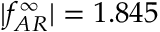Convert formula to latex. <formula><loc_0><loc_0><loc_500><loc_500>| f _ { A R } ^ { \infty } | = 1 . 8 4 5</formula> 